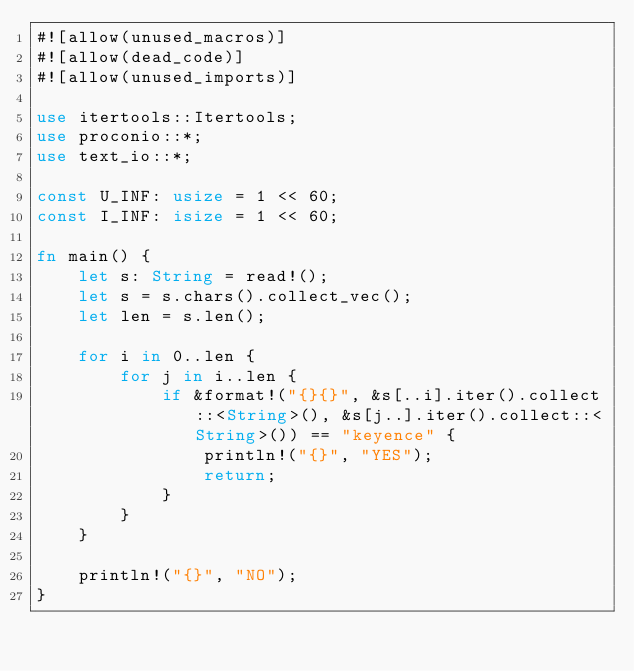Convert code to text. <code><loc_0><loc_0><loc_500><loc_500><_Rust_>#![allow(unused_macros)]
#![allow(dead_code)]
#![allow(unused_imports)]

use itertools::Itertools;
use proconio::*;
use text_io::*;

const U_INF: usize = 1 << 60;
const I_INF: isize = 1 << 60;

fn main() {
    let s: String = read!();
    let s = s.chars().collect_vec();
    let len = s.len();

    for i in 0..len {
        for j in i..len {
            if &format!("{}{}", &s[..i].iter().collect::<String>(), &s[j..].iter().collect::<String>()) == "keyence" {
                println!("{}", "YES");
                return;
            }
        }
    }

    println!("{}", "NO");
}
</code> 